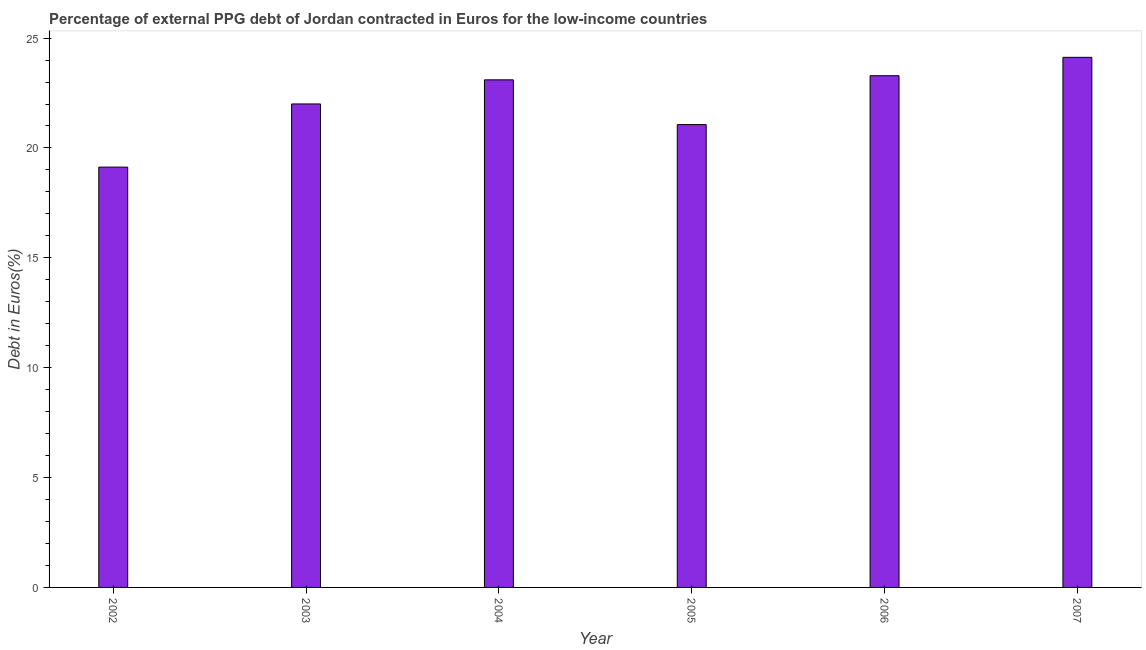Does the graph contain grids?
Give a very brief answer. No. What is the title of the graph?
Ensure brevity in your answer.  Percentage of external PPG debt of Jordan contracted in Euros for the low-income countries. What is the label or title of the Y-axis?
Offer a terse response. Debt in Euros(%). What is the currency composition of ppg debt in 2004?
Your response must be concise. 23.1. Across all years, what is the maximum currency composition of ppg debt?
Ensure brevity in your answer.  24.12. Across all years, what is the minimum currency composition of ppg debt?
Your answer should be compact. 19.13. What is the sum of the currency composition of ppg debt?
Offer a terse response. 132.71. What is the difference between the currency composition of ppg debt in 2003 and 2007?
Ensure brevity in your answer.  -2.12. What is the average currency composition of ppg debt per year?
Your response must be concise. 22.12. What is the median currency composition of ppg debt?
Make the answer very short. 22.55. What is the ratio of the currency composition of ppg debt in 2005 to that in 2007?
Ensure brevity in your answer.  0.87. What is the difference between the highest and the second highest currency composition of ppg debt?
Provide a succinct answer. 0.84. Is the sum of the currency composition of ppg debt in 2002 and 2007 greater than the maximum currency composition of ppg debt across all years?
Your answer should be very brief. Yes. What is the difference between the highest and the lowest currency composition of ppg debt?
Your answer should be compact. 5. Are all the bars in the graph horizontal?
Your answer should be very brief. No. How many years are there in the graph?
Provide a succinct answer. 6. What is the Debt in Euros(%) in 2002?
Provide a succinct answer. 19.13. What is the Debt in Euros(%) of 2003?
Offer a terse response. 22. What is the Debt in Euros(%) in 2004?
Offer a terse response. 23.1. What is the Debt in Euros(%) in 2005?
Provide a succinct answer. 21.06. What is the Debt in Euros(%) of 2006?
Make the answer very short. 23.29. What is the Debt in Euros(%) of 2007?
Your response must be concise. 24.12. What is the difference between the Debt in Euros(%) in 2002 and 2003?
Ensure brevity in your answer.  -2.87. What is the difference between the Debt in Euros(%) in 2002 and 2004?
Your answer should be very brief. -3.97. What is the difference between the Debt in Euros(%) in 2002 and 2005?
Your response must be concise. -1.93. What is the difference between the Debt in Euros(%) in 2002 and 2006?
Provide a short and direct response. -4.16. What is the difference between the Debt in Euros(%) in 2002 and 2007?
Your answer should be compact. -5. What is the difference between the Debt in Euros(%) in 2003 and 2004?
Your answer should be very brief. -1.1. What is the difference between the Debt in Euros(%) in 2003 and 2005?
Keep it short and to the point. 0.94. What is the difference between the Debt in Euros(%) in 2003 and 2006?
Your response must be concise. -1.28. What is the difference between the Debt in Euros(%) in 2003 and 2007?
Provide a succinct answer. -2.12. What is the difference between the Debt in Euros(%) in 2004 and 2005?
Offer a very short reply. 2.04. What is the difference between the Debt in Euros(%) in 2004 and 2006?
Keep it short and to the point. -0.19. What is the difference between the Debt in Euros(%) in 2004 and 2007?
Make the answer very short. -1.02. What is the difference between the Debt in Euros(%) in 2005 and 2006?
Give a very brief answer. -2.23. What is the difference between the Debt in Euros(%) in 2005 and 2007?
Make the answer very short. -3.06. What is the difference between the Debt in Euros(%) in 2006 and 2007?
Provide a short and direct response. -0.84. What is the ratio of the Debt in Euros(%) in 2002 to that in 2003?
Your answer should be compact. 0.87. What is the ratio of the Debt in Euros(%) in 2002 to that in 2004?
Give a very brief answer. 0.83. What is the ratio of the Debt in Euros(%) in 2002 to that in 2005?
Give a very brief answer. 0.91. What is the ratio of the Debt in Euros(%) in 2002 to that in 2006?
Provide a short and direct response. 0.82. What is the ratio of the Debt in Euros(%) in 2002 to that in 2007?
Ensure brevity in your answer.  0.79. What is the ratio of the Debt in Euros(%) in 2003 to that in 2004?
Provide a short and direct response. 0.95. What is the ratio of the Debt in Euros(%) in 2003 to that in 2005?
Provide a succinct answer. 1.04. What is the ratio of the Debt in Euros(%) in 2003 to that in 2006?
Give a very brief answer. 0.94. What is the ratio of the Debt in Euros(%) in 2003 to that in 2007?
Offer a very short reply. 0.91. What is the ratio of the Debt in Euros(%) in 2004 to that in 2005?
Offer a very short reply. 1.1. What is the ratio of the Debt in Euros(%) in 2004 to that in 2006?
Your response must be concise. 0.99. What is the ratio of the Debt in Euros(%) in 2004 to that in 2007?
Your answer should be very brief. 0.96. What is the ratio of the Debt in Euros(%) in 2005 to that in 2006?
Ensure brevity in your answer.  0.9. What is the ratio of the Debt in Euros(%) in 2005 to that in 2007?
Keep it short and to the point. 0.87. 